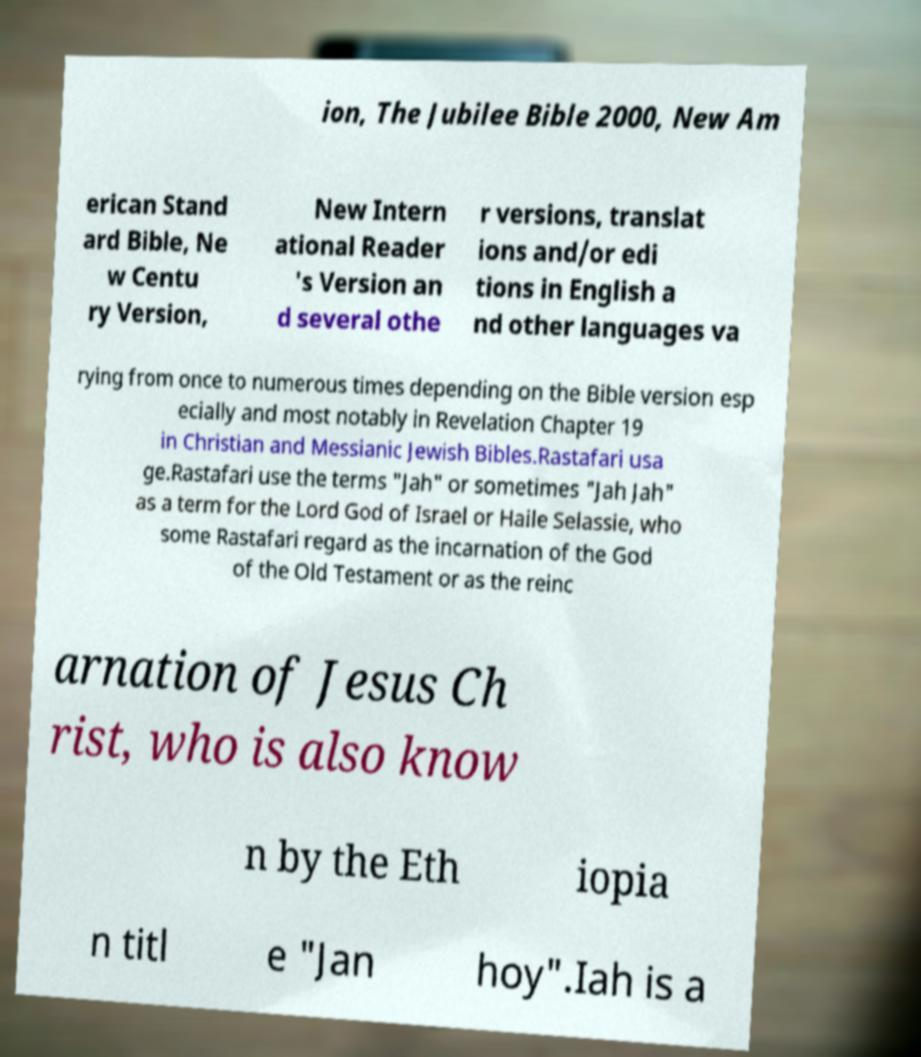Can you accurately transcribe the text from the provided image for me? ion, The Jubilee Bible 2000, New Am erican Stand ard Bible, Ne w Centu ry Version, New Intern ational Reader 's Version an d several othe r versions, translat ions and/or edi tions in English a nd other languages va rying from once to numerous times depending on the Bible version esp ecially and most notably in Revelation Chapter 19 in Christian and Messianic Jewish Bibles.Rastafari usa ge.Rastafari use the terms "Jah" or sometimes "Jah Jah" as a term for the Lord God of Israel or Haile Selassie, who some Rastafari regard as the incarnation of the God of the Old Testament or as the reinc arnation of Jesus Ch rist, who is also know n by the Eth iopia n titl e "Jan hoy".Iah is a 